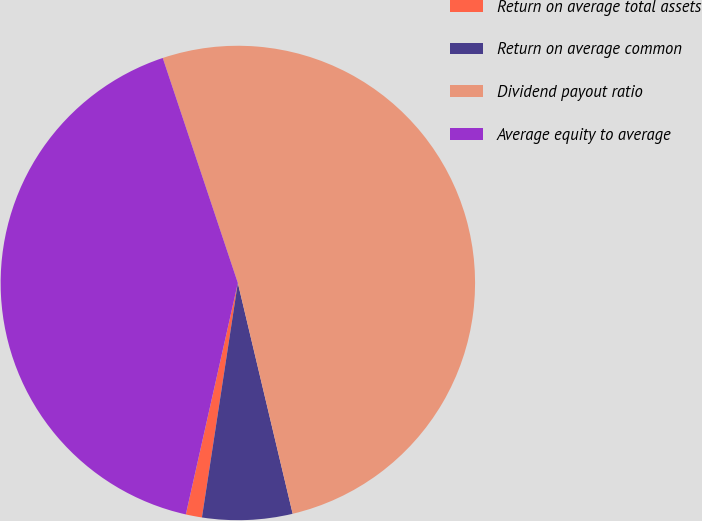<chart> <loc_0><loc_0><loc_500><loc_500><pie_chart><fcel>Return on average total assets<fcel>Return on average common<fcel>Dividend payout ratio<fcel>Average equity to average<nl><fcel>1.1%<fcel>6.13%<fcel>51.41%<fcel>41.35%<nl></chart> 